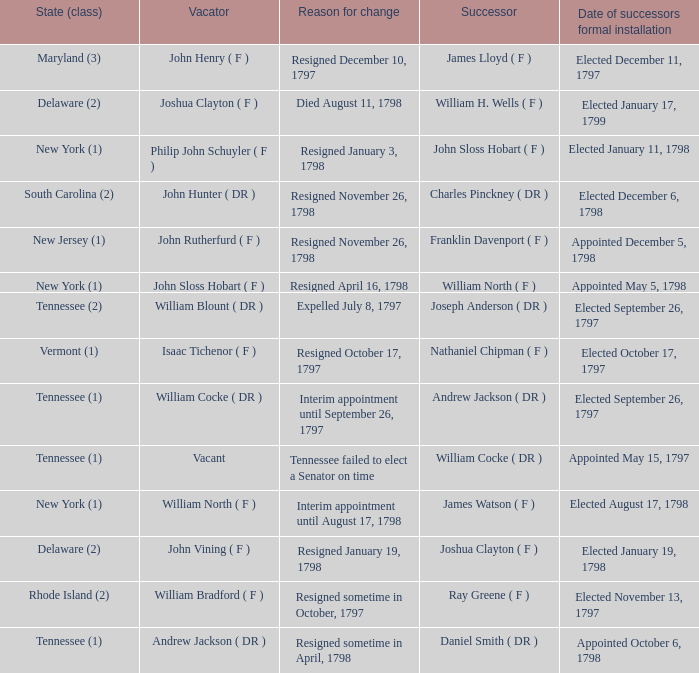What are all the states (class) when the successor was Joseph Anderson ( DR )? Tennessee (2). 